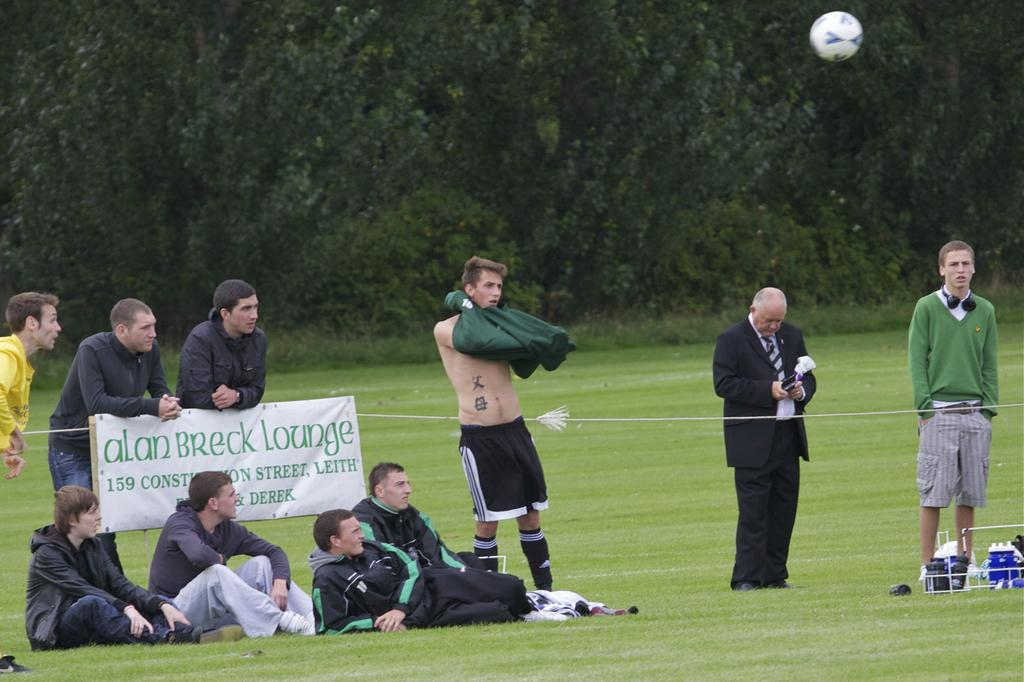How many people are sitting on the ground in the image? There are four persons sitting on the ground in the image. What is the ground covered with? The ground is covered in greenery. Are there any other people visible in the image besides the seated individuals? Yes, there are other persons standing behind the seated individuals. What can be seen in the background of the image? There are trees in the background of the image. What type of business is being conducted in the image? There is no indication of any business being conducted in the image; it primarily features people sitting and standing in a natural setting. 